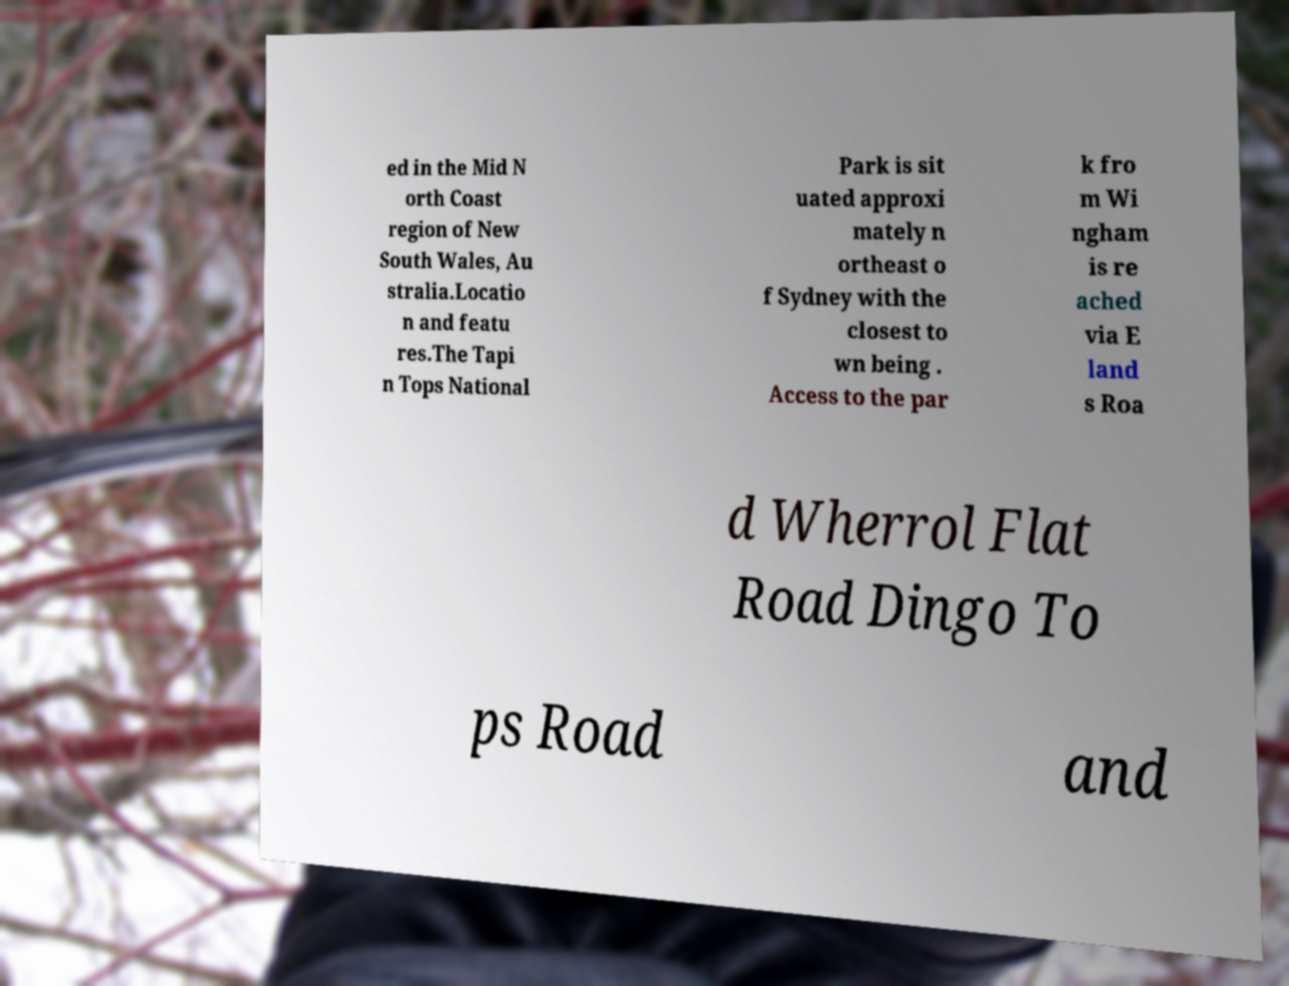Can you accurately transcribe the text from the provided image for me? ed in the Mid N orth Coast region of New South Wales, Au stralia.Locatio n and featu res.The Tapi n Tops National Park is sit uated approxi mately n ortheast o f Sydney with the closest to wn being . Access to the par k fro m Wi ngham is re ached via E land s Roa d Wherrol Flat Road Dingo To ps Road and 